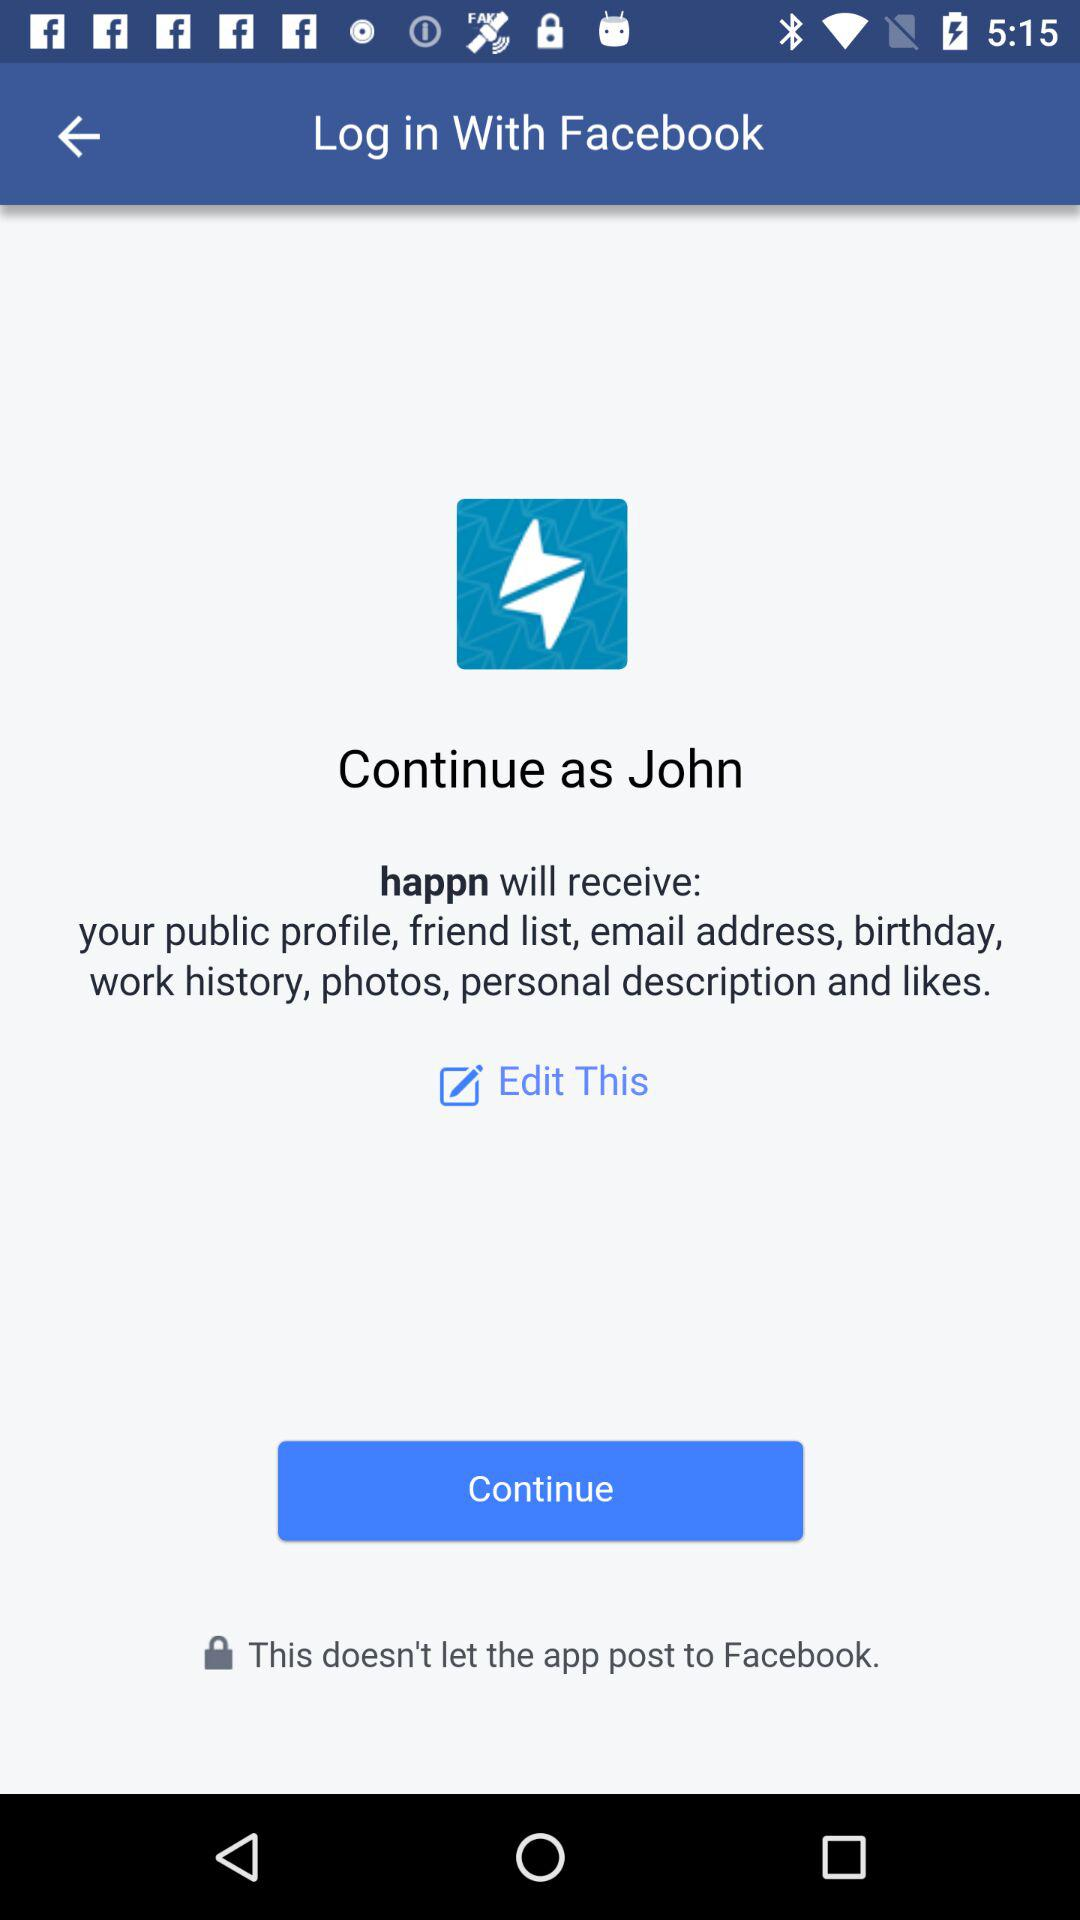What is the name of the user? The name of the user is John. 